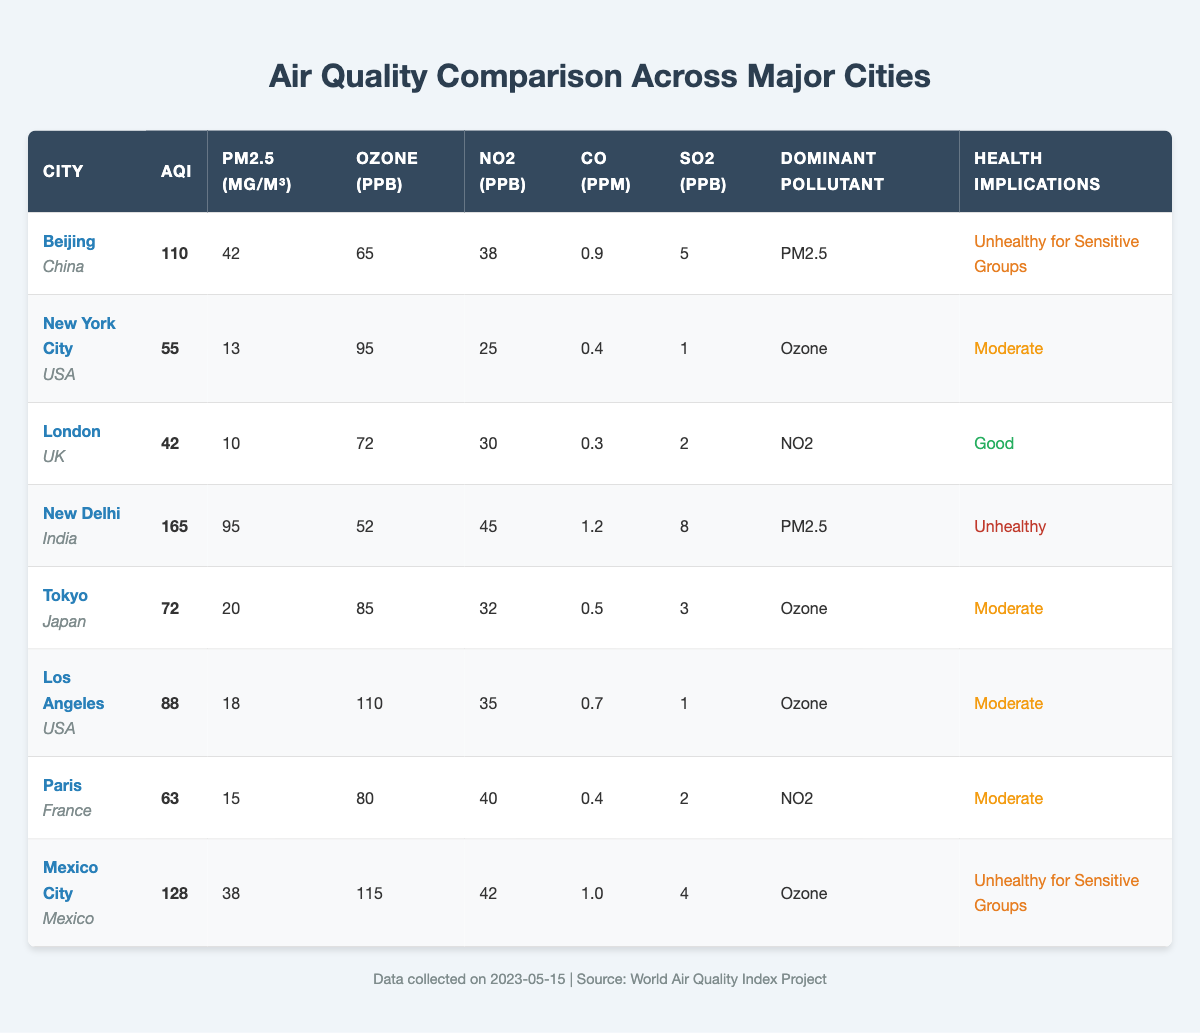What is the AQI value for New Delhi? From the table, we can directly see the AQI value for New Delhi listed under its respective row. It indicates that the AQI value is 165.
Answer: 165 Which city has the lowest PM2.5 concentration? By examining the PM2.5 column across all cities, we can identify that London has the lowest PM2.5 concentration at 10 µg/m³.
Answer: 10 µg/m³ Is the dominant pollutant in Mexico City ozone? Looking at the row for Mexico City, the dominant pollutant is listed as ozone; therefore, the statement is true.
Answer: Yes What is the average AQI for all the cities listed? First, we sum the AQI values: 110 + 55 + 42 + 165 + 72 + 88 + 63 + 128 = 723. There are 8 cities, so we divide 723 by 8, which gives us 90.375.
Answer: 90.375 Which city has the highest Ozone levels, and what is that level? By scanning through the Ozone column, we find that Los Angeles has the highest ozone level at 110 ppb.
Answer: 110 ppb Is London classified as having "Unhealthy" air quality? According to the health implications listed for London, it is classified as "Good," so the statement is false.
Answer: No How does the AQI of Beijing compare to that of New York City? The AQI for Beijing is 110, while for New York City, it is 55. Therefore, Beijing has a higher AQI than New York City by 55.
Answer: 55 Which two cities have the same health implication categorization? By reviewing the health implications column, we see that New York City, Tokyo, Los Angeles, and Paris are all categorized as "Moderate." This means these four cities have the same health implications.
Answer: New York City, Tokyo, Los Angeles, and Paris What is the difference in CO levels between New Delhi and Beijing? For New Delhi, the CO level is 1.2 ppm, and for Beijing, it is 0.9 ppm. The difference is 1.2 - 0.9 = 0.3 ppm.
Answer: 0.3 ppm 